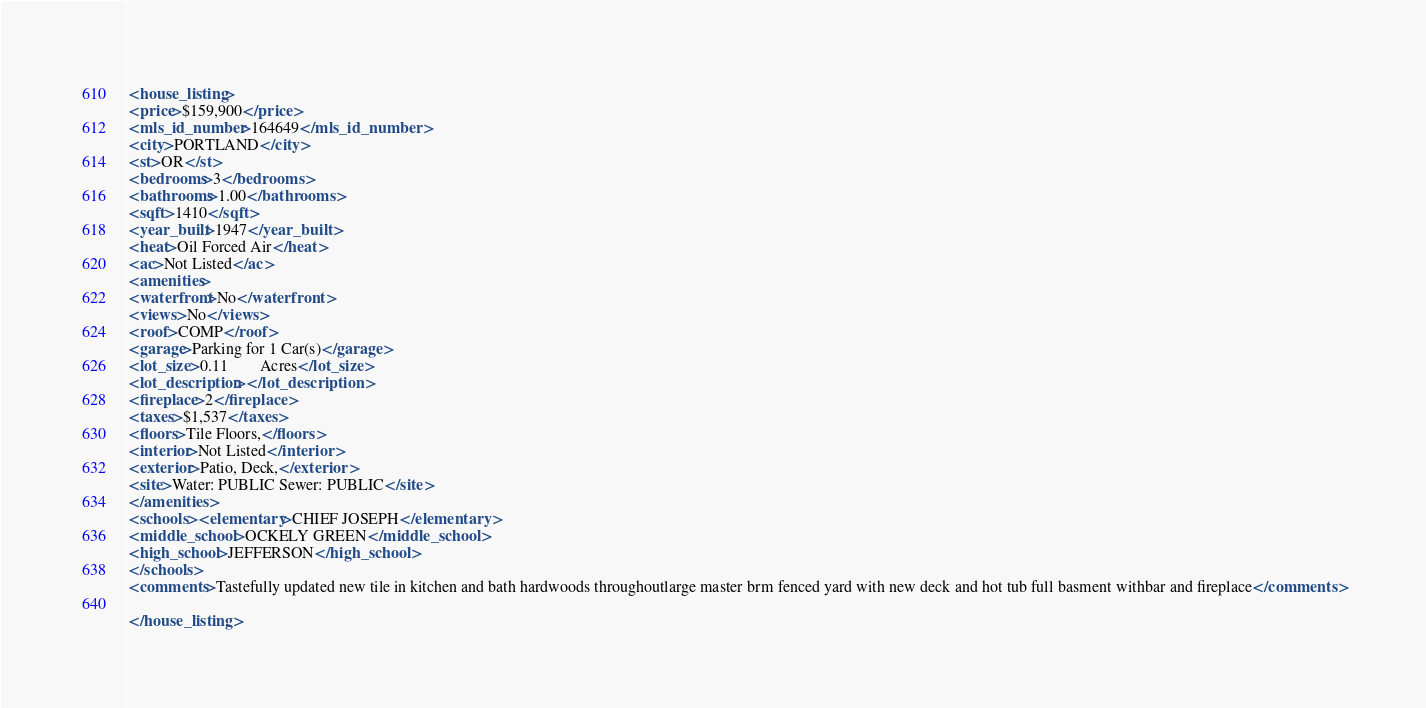<code> <loc_0><loc_0><loc_500><loc_500><_XML_><house_listing>
<price>$159,900</price>
<mls_id_number>164649</mls_id_number>
<city>PORTLAND</city>
<st>OR</st>
<bedrooms>3</bedrooms>
<bathrooms>1.00</bathrooms>
<sqft>1410</sqft>
<year_built>1947</year_built>
<heat>Oil Forced Air</heat>
<ac>Not Listed</ac>
<amenities>
<waterfront>No</waterfront>
<views>No</views>
<roof>COMP</roof>
<garage>Parking for 1 Car(s)</garage>
<lot_size>0.11        Acres</lot_size>
<lot_description></lot_description>
<fireplace>2</fireplace>
<taxes>$1,537</taxes>
<floors>Tile Floors,</floors>
<interior>Not Listed</interior>
<exterior>Patio, Deck,</exterior>
<site>Water: PUBLIC Sewer: PUBLIC</site>
</amenities>
<schools><elementary>CHIEF JOSEPH</elementary>
<middle_school>OCKELY GREEN</middle_school>
<high_school>JEFFERSON</high_school>
</schools>
<comments>Tastefully updated new tile in kitchen and bath hardwoods throughoutlarge master brm fenced yard with new deck and hot tub full basment withbar and fireplace</comments>

</house_listing>



</code> 